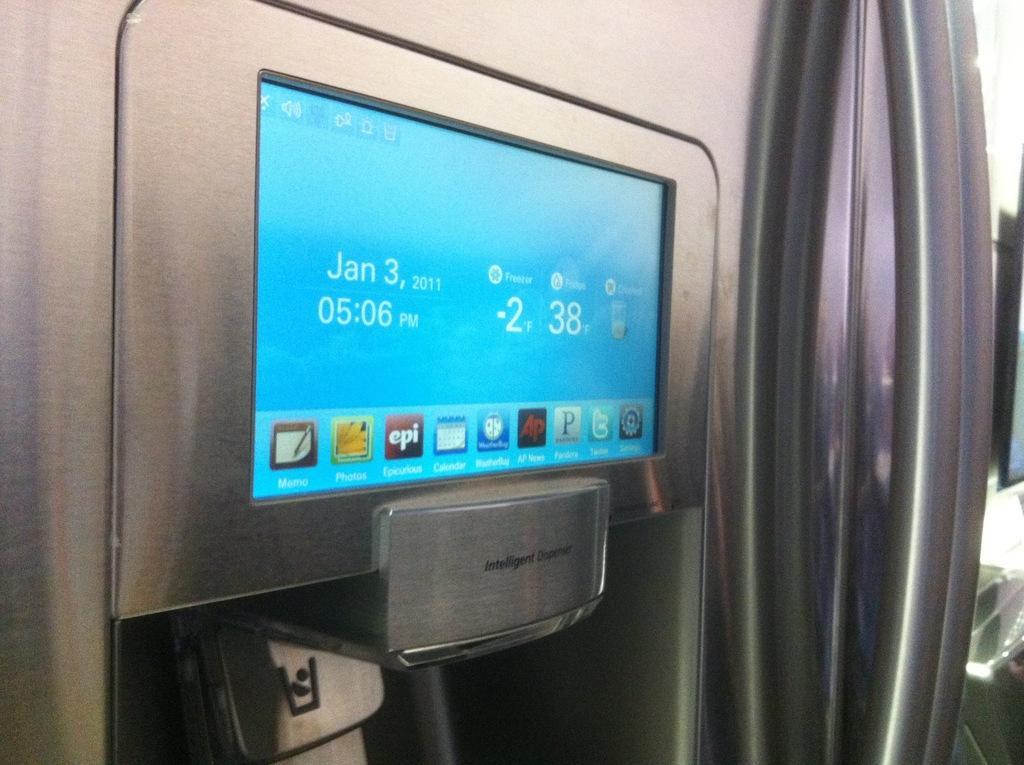In one or two sentences, can you explain what this image depicts? In this image we can see a display screen with some pictures and numbers on a device. 